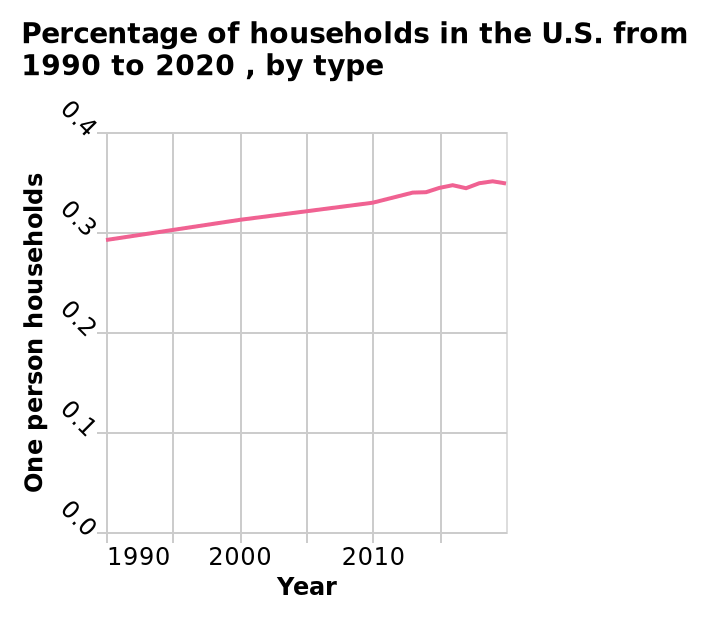<image>
What is represented on the x-axis? The x-axis represents the years from 1990 to 2020. 